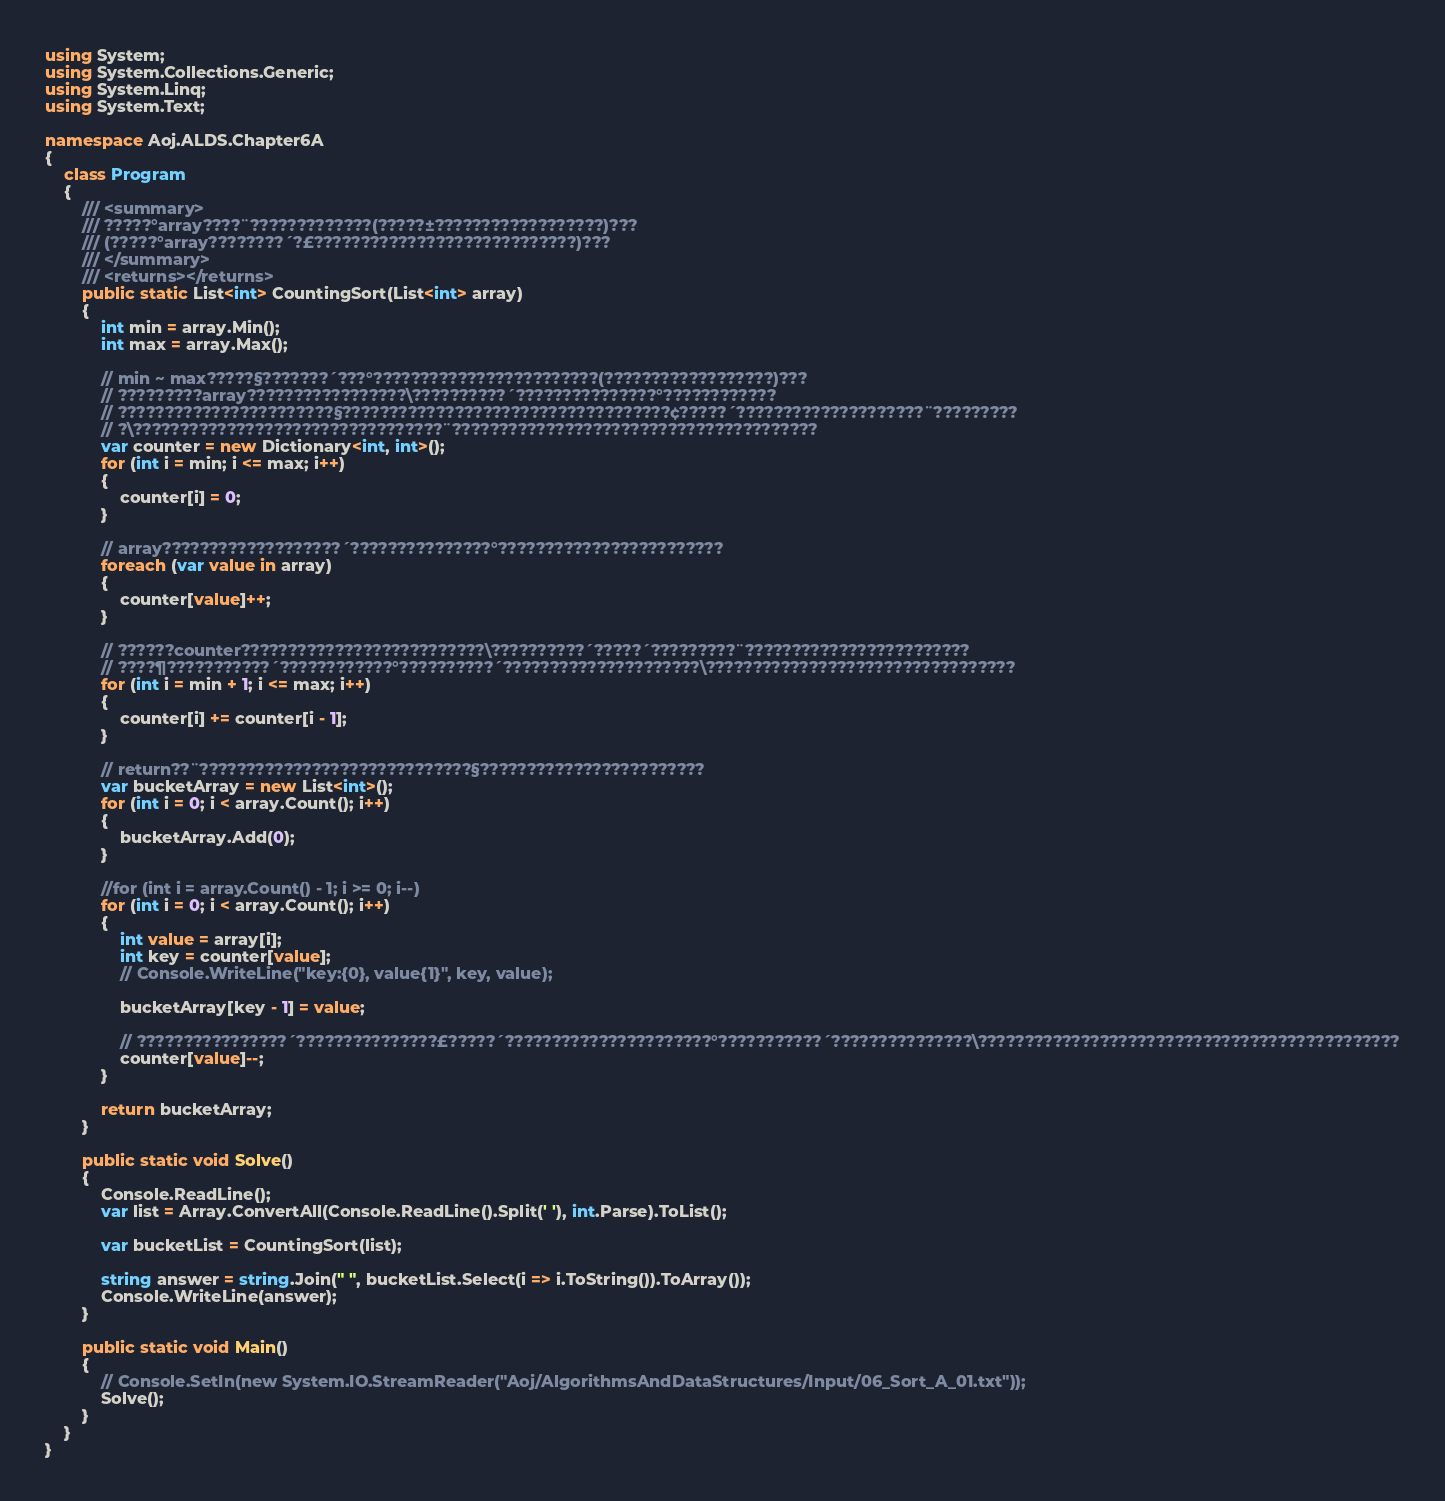<code> <loc_0><loc_0><loc_500><loc_500><_C#_>using System;
using System.Collections.Generic;
using System.Linq;
using System.Text;

namespace Aoj.ALDS.Chapter6A
{
    class Program
    {
        /// <summary>
        /// ?????°array????¨?????????????(?????±??????????????????)???
        /// (?????°array????????´?£????????????????????????????)???
        /// </summary>
        /// <returns></returns>
        public static List<int> CountingSort(List<int> array)
        {
            int min = array.Min();
            int max = array.Max();

            // min ~ max?????§???????´???°????????????????????????(??????????????????)???
            // ?????????array?????????????????\??????????´???????????????°????????????
            // ???????????????????????§???????????????????????????????????¢?????´????????????????????¨?????????
            // ?\?????????????????????????????????¨???????????????????????????????????????
            var counter = new Dictionary<int, int>();
            for (int i = min; i <= max; i++)
            {
                counter[i] = 0;
            }

            // array???????????????????´???????????????°????????????????????????
            foreach (var value in array)
            {
                counter[value]++;
            }

            // ??????counter??????????????????????????\??????????´?????´?????????¨????????????????????????
            // ????¶???????????´????????????°??????????´?????????????????????\?????????????????????????????????
            for (int i = min + 1; i <= max; i++)
            {
                counter[i] += counter[i - 1];
            }

            // return??¨?????????????????????????????§????????????????????????
            var bucketArray = new List<int>();
            for (int i = 0; i < array.Count(); i++)
            {
                bucketArray.Add(0);
            }

            //for (int i = array.Count() - 1; i >= 0; i--)
            for (int i = 0; i < array.Count(); i++)
            {
                int value = array[i];
                int key = counter[value];
                // Console.WriteLine("key:{0}, value{1}", key, value);

                bucketArray[key - 1] = value;

                // ????????????????´???????????????£?????´??????????????????????°???????????´???????????????\?????????????????????????????????????????????
                counter[value]--;
            }

            return bucketArray;
        }

        public static void Solve()
        {
            Console.ReadLine();
            var list = Array.ConvertAll(Console.ReadLine().Split(' '), int.Parse).ToList();

            var bucketList = CountingSort(list);

            string answer = string.Join(" ", bucketList.Select(i => i.ToString()).ToArray());
            Console.WriteLine(answer);
        }

        public static void Main()
        {
            // Console.SetIn(new System.IO.StreamReader("Aoj/AlgorithmsAndDataStructures/Input/06_Sort_A_01.txt"));
            Solve();
        }
    }
}</code> 